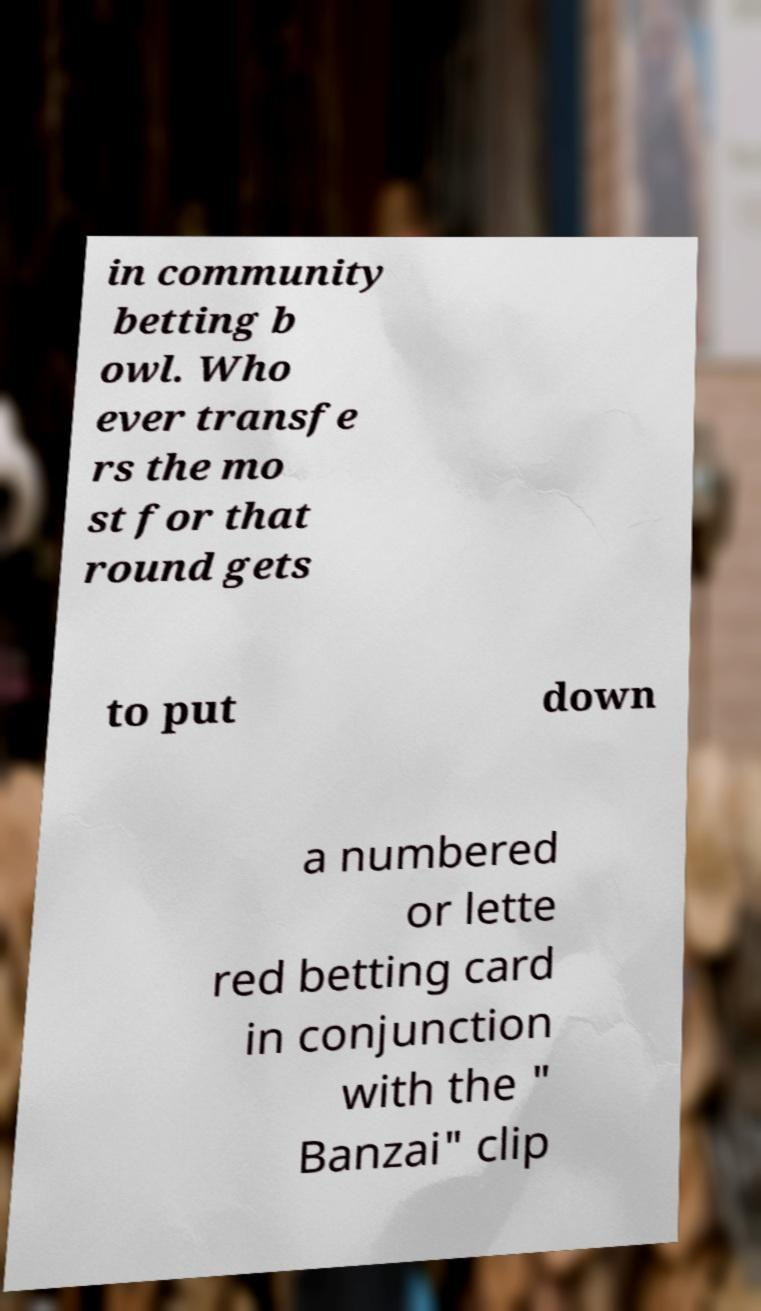Please identify and transcribe the text found in this image. in community betting b owl. Who ever transfe rs the mo st for that round gets to put down a numbered or lette red betting card in conjunction with the " Banzai" clip 